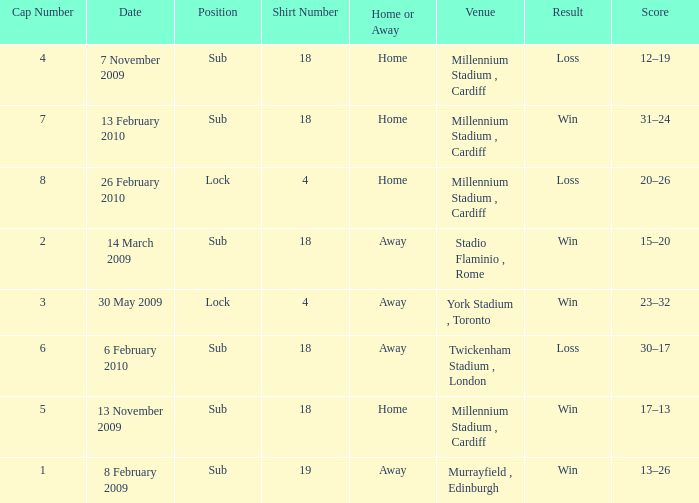Can you tell me the Home or the Away that has the Shirt Number larger than 18? Away. 